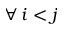<formula> <loc_0><loc_0><loc_500><loc_500>\forall \, i < j</formula> 